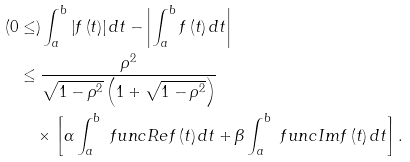Convert formula to latex. <formula><loc_0><loc_0><loc_500><loc_500>( 0 & \leq ) \int _ { a } ^ { b } \left | f \left ( t \right ) \right | d t - \left | \int _ { a } ^ { b } f \left ( t \right ) d t \right | \\ & \leq \frac { \rho ^ { 2 } } { \sqrt { 1 - \rho ^ { 2 } } \left ( 1 + \sqrt { 1 - \rho ^ { 2 } } \right ) } \\ & \quad \times \left [ \alpha \int _ { a } ^ { b } \ f u n c { R e } f \left ( t \right ) d t + \beta \int _ { a } ^ { b } \ f u n c { I m } f \left ( t \right ) d t \right ] .</formula> 